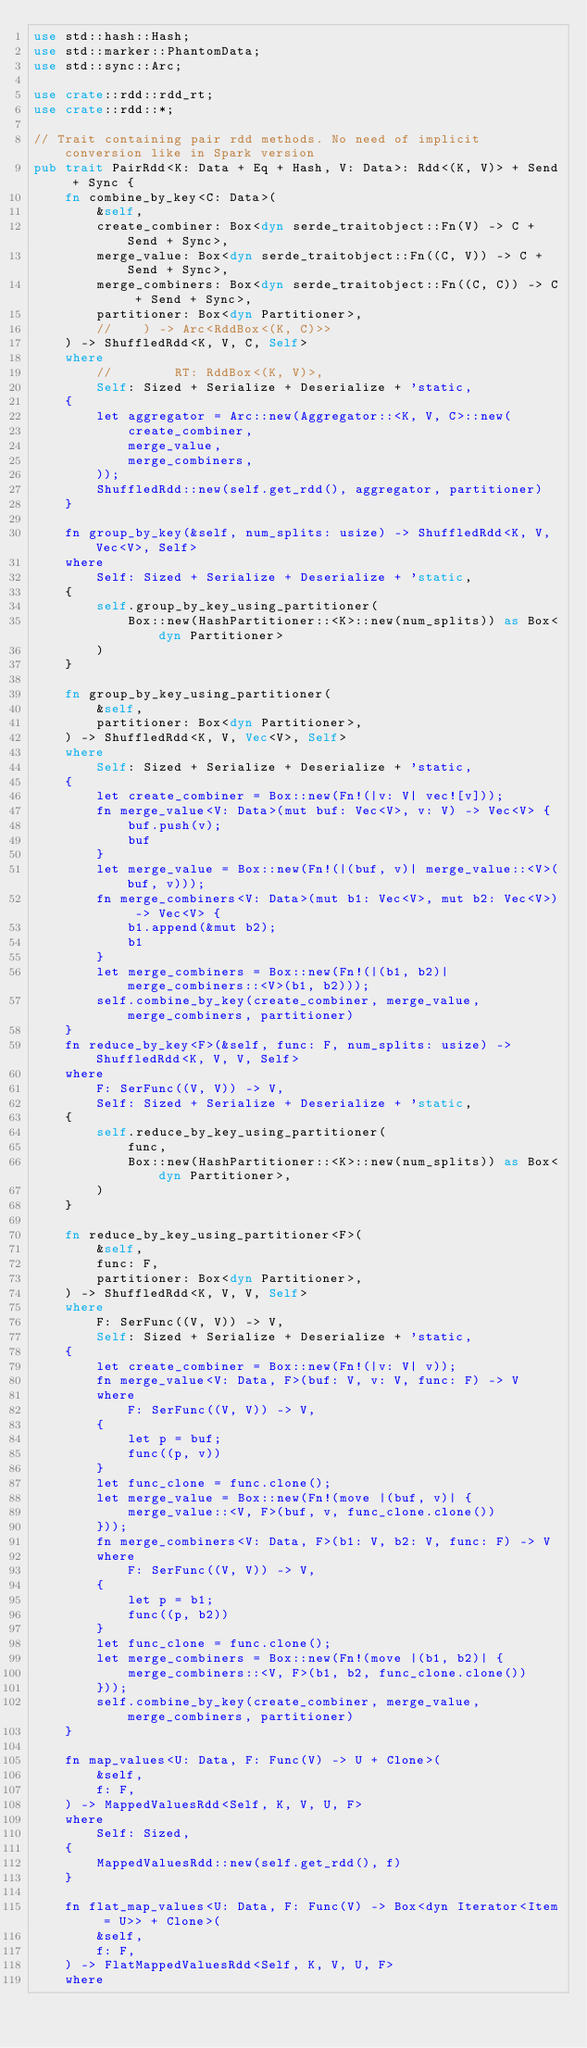Convert code to text. <code><loc_0><loc_0><loc_500><loc_500><_Rust_>use std::hash::Hash;
use std::marker::PhantomData;
use std::sync::Arc;

use crate::rdd::rdd_rt;
use crate::rdd::*;

// Trait containing pair rdd methods. No need of implicit conversion like in Spark version
pub trait PairRdd<K: Data + Eq + Hash, V: Data>: Rdd<(K, V)> + Send + Sync {
    fn combine_by_key<C: Data>(
        &self,
        create_combiner: Box<dyn serde_traitobject::Fn(V) -> C + Send + Sync>,
        merge_value: Box<dyn serde_traitobject::Fn((C, V)) -> C + Send + Sync>,
        merge_combiners: Box<dyn serde_traitobject::Fn((C, C)) -> C + Send + Sync>,
        partitioner: Box<dyn Partitioner>,
        //    ) -> Arc<RddBox<(K, C)>>
    ) -> ShuffledRdd<K, V, C, Self>
    where
        //        RT: RddBox<(K, V)>,
        Self: Sized + Serialize + Deserialize + 'static,
    {
        let aggregator = Arc::new(Aggregator::<K, V, C>::new(
            create_combiner,
            merge_value,
            merge_combiners,
        ));
        ShuffledRdd::new(self.get_rdd(), aggregator, partitioner)
    }

    fn group_by_key(&self, num_splits: usize) -> ShuffledRdd<K, V, Vec<V>, Self>
    where
        Self: Sized + Serialize + Deserialize + 'static,
    {
        self.group_by_key_using_partitioner(
            Box::new(HashPartitioner::<K>::new(num_splits)) as Box<dyn Partitioner>
        )
    }

    fn group_by_key_using_partitioner(
        &self,
        partitioner: Box<dyn Partitioner>,
    ) -> ShuffledRdd<K, V, Vec<V>, Self>
    where
        Self: Sized + Serialize + Deserialize + 'static,
    {
        let create_combiner = Box::new(Fn!(|v: V| vec![v]));
        fn merge_value<V: Data>(mut buf: Vec<V>, v: V) -> Vec<V> {
            buf.push(v);
            buf
        }
        let merge_value = Box::new(Fn!(|(buf, v)| merge_value::<V>(buf, v)));
        fn merge_combiners<V: Data>(mut b1: Vec<V>, mut b2: Vec<V>) -> Vec<V> {
            b1.append(&mut b2);
            b1
        }
        let merge_combiners = Box::new(Fn!(|(b1, b2)| merge_combiners::<V>(b1, b2)));
        self.combine_by_key(create_combiner, merge_value, merge_combiners, partitioner)
    }
    fn reduce_by_key<F>(&self, func: F, num_splits: usize) -> ShuffledRdd<K, V, V, Self>
    where
        F: SerFunc((V, V)) -> V,
        Self: Sized + Serialize + Deserialize + 'static,
    {
        self.reduce_by_key_using_partitioner(
            func,
            Box::new(HashPartitioner::<K>::new(num_splits)) as Box<dyn Partitioner>,
        )
    }

    fn reduce_by_key_using_partitioner<F>(
        &self,
        func: F,
        partitioner: Box<dyn Partitioner>,
    ) -> ShuffledRdd<K, V, V, Self>
    where
        F: SerFunc((V, V)) -> V,
        Self: Sized + Serialize + Deserialize + 'static,
    {
        let create_combiner = Box::new(Fn!(|v: V| v));
        fn merge_value<V: Data, F>(buf: V, v: V, func: F) -> V
        where
            F: SerFunc((V, V)) -> V,
        {
            let p = buf;
            func((p, v))
        }
        let func_clone = func.clone();
        let merge_value = Box::new(Fn!(move |(buf, v)| {
            merge_value::<V, F>(buf, v, func_clone.clone())
        }));
        fn merge_combiners<V: Data, F>(b1: V, b2: V, func: F) -> V
        where
            F: SerFunc((V, V)) -> V,
        {
            let p = b1;
            func((p, b2))
        }
        let func_clone = func.clone();
        let merge_combiners = Box::new(Fn!(move |(b1, b2)| {
            merge_combiners::<V, F>(b1, b2, func_clone.clone())
        }));
        self.combine_by_key(create_combiner, merge_value, merge_combiners, partitioner)
    }

    fn map_values<U: Data, F: Func(V) -> U + Clone>(
        &self,
        f: F,
    ) -> MappedValuesRdd<Self, K, V, U, F>
    where
        Self: Sized,
    {
        MappedValuesRdd::new(self.get_rdd(), f)
    }

    fn flat_map_values<U: Data, F: Func(V) -> Box<dyn Iterator<Item = U>> + Clone>(
        &self,
        f: F,
    ) -> FlatMappedValuesRdd<Self, K, V, U, F>
    where</code> 